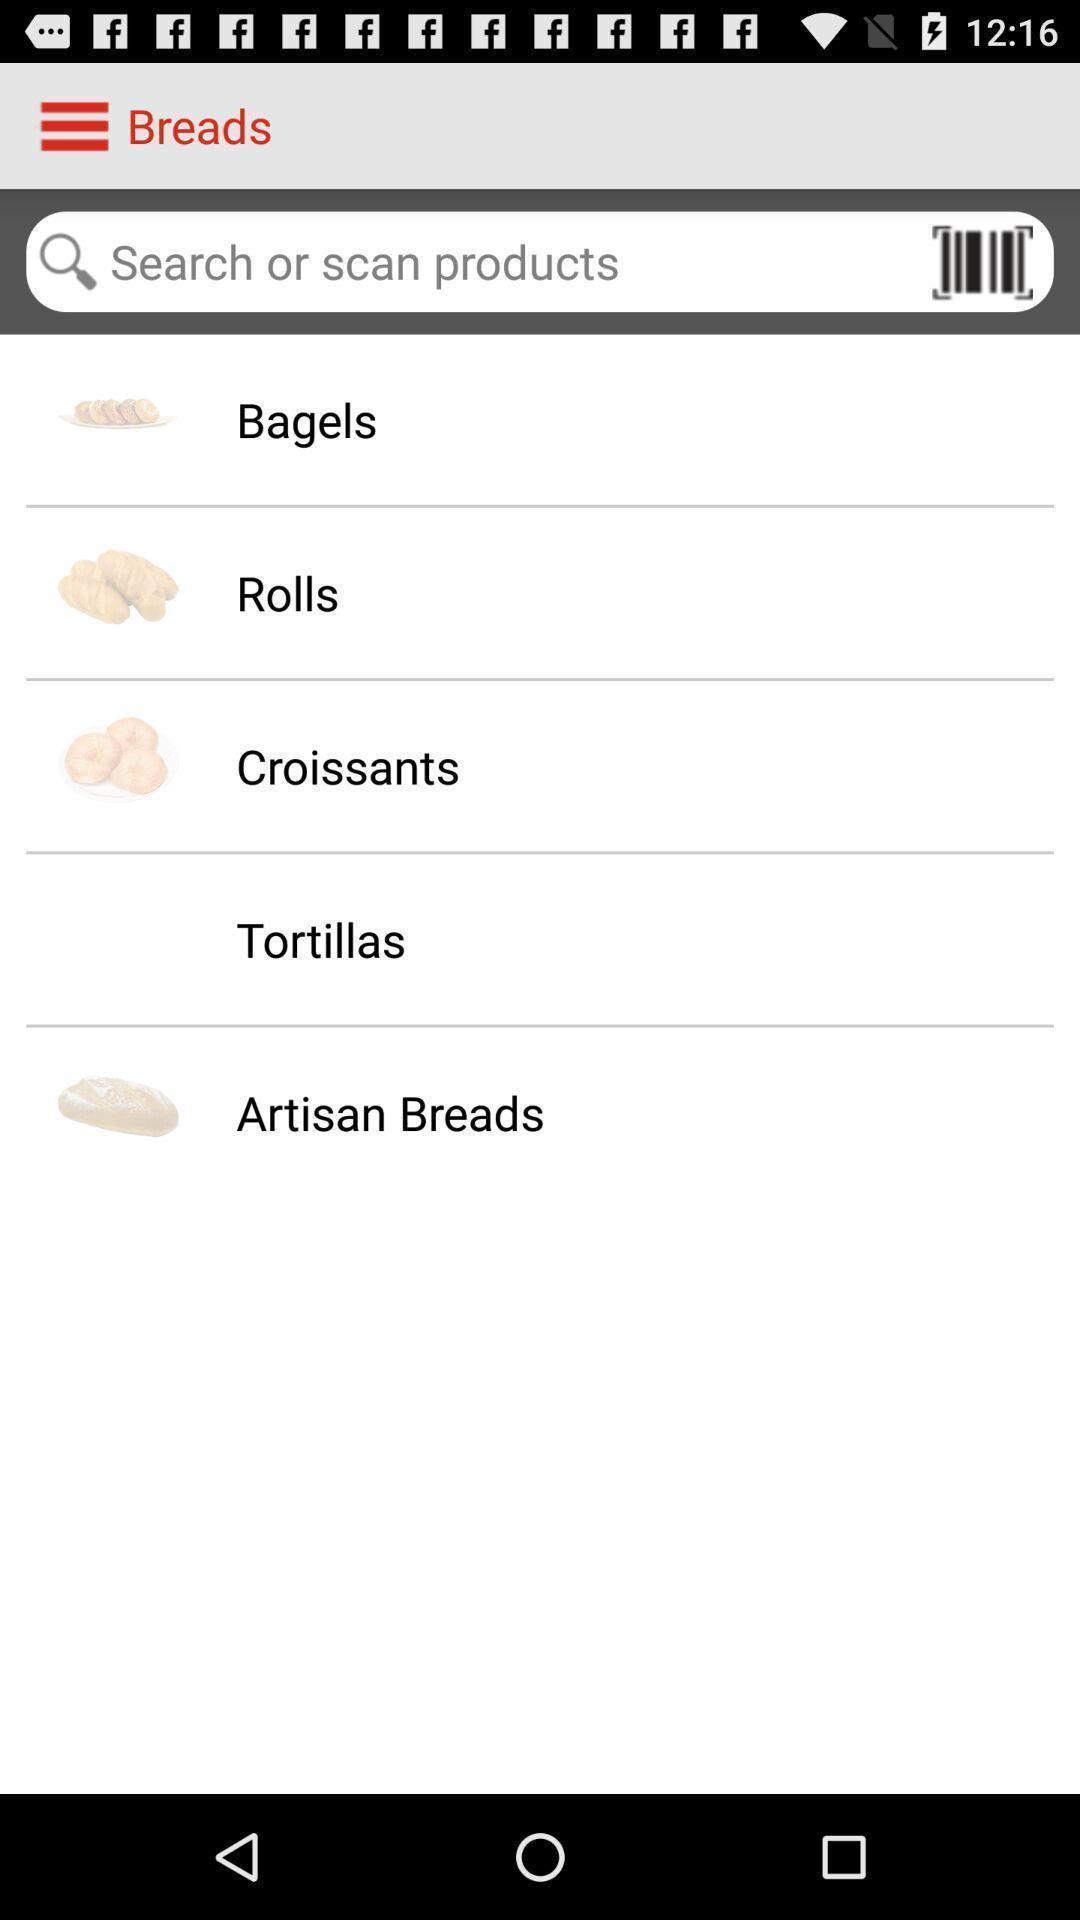Describe the content in this image. Page displaying various breads in a grocery app. 